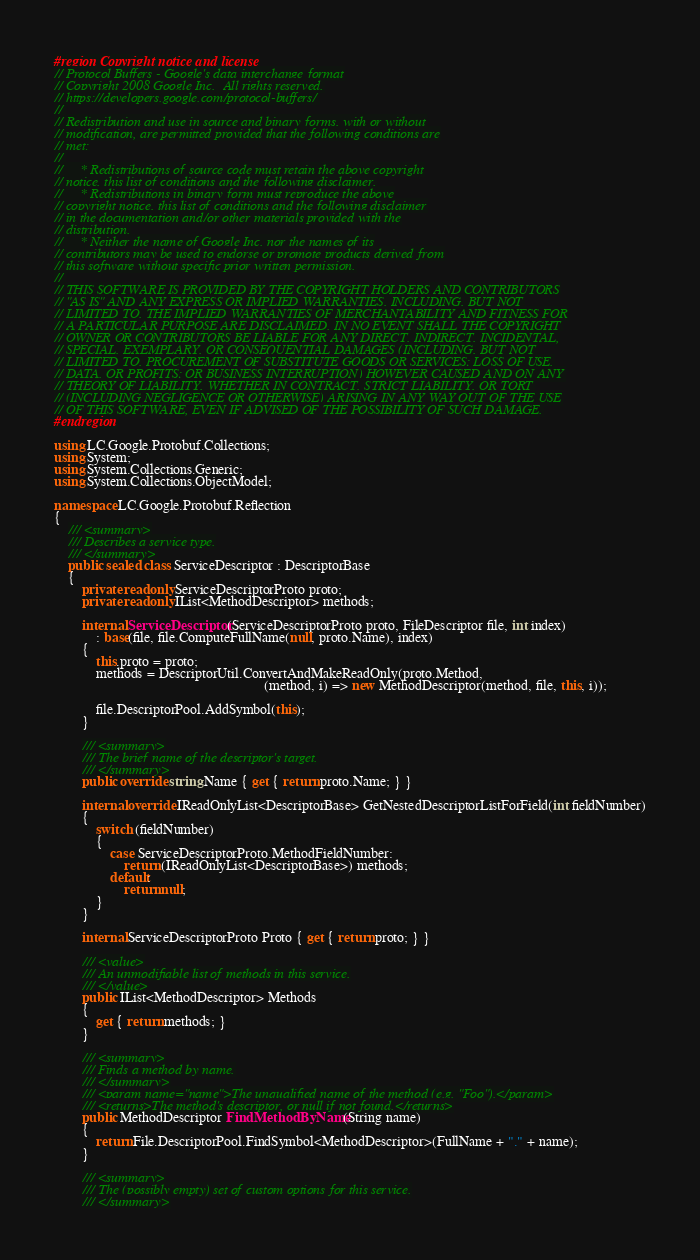<code> <loc_0><loc_0><loc_500><loc_500><_C#_>#region Copyright notice and license
// Protocol Buffers - Google's data interchange format
// Copyright 2008 Google Inc.  All rights reserved.
// https://developers.google.com/protocol-buffers/
//
// Redistribution and use in source and binary forms, with or without
// modification, are permitted provided that the following conditions are
// met:
//
//     * Redistributions of source code must retain the above copyright
// notice, this list of conditions and the following disclaimer.
//     * Redistributions in binary form must reproduce the above
// copyright notice, this list of conditions and the following disclaimer
// in the documentation and/or other materials provided with the
// distribution.
//     * Neither the name of Google Inc. nor the names of its
// contributors may be used to endorse or promote products derived from
// this software without specific prior written permission.
//
// THIS SOFTWARE IS PROVIDED BY THE COPYRIGHT HOLDERS AND CONTRIBUTORS
// "AS IS" AND ANY EXPRESS OR IMPLIED WARRANTIES, INCLUDING, BUT NOT
// LIMITED TO, THE IMPLIED WARRANTIES OF MERCHANTABILITY AND FITNESS FOR
// A PARTICULAR PURPOSE ARE DISCLAIMED. IN NO EVENT SHALL THE COPYRIGHT
// OWNER OR CONTRIBUTORS BE LIABLE FOR ANY DIRECT, INDIRECT, INCIDENTAL,
// SPECIAL, EXEMPLARY, OR CONSEQUENTIAL DAMAGES (INCLUDING, BUT NOT
// LIMITED TO, PROCUREMENT OF SUBSTITUTE GOODS OR SERVICES; LOSS OF USE,
// DATA, OR PROFITS; OR BUSINESS INTERRUPTION) HOWEVER CAUSED AND ON ANY
// THEORY OF LIABILITY, WHETHER IN CONTRACT, STRICT LIABILITY, OR TORT
// (INCLUDING NEGLIGENCE OR OTHERWISE) ARISING IN ANY WAY OUT OF THE USE
// OF THIS SOFTWARE, EVEN IF ADVISED OF THE POSSIBILITY OF SUCH DAMAGE.
#endregion

using LC.Google.Protobuf.Collections;
using System;
using System.Collections.Generic;
using System.Collections.ObjectModel;

namespace LC.Google.Protobuf.Reflection
{
    /// <summary>
    /// Describes a service type.
    /// </summary>
    public sealed class ServiceDescriptor : DescriptorBase
    {
        private readonly ServiceDescriptorProto proto;
        private readonly IList<MethodDescriptor> methods;

        internal ServiceDescriptor(ServiceDescriptorProto proto, FileDescriptor file, int index)
            : base(file, file.ComputeFullName(null, proto.Name), index)
        {
            this.proto = proto;
            methods = DescriptorUtil.ConvertAndMakeReadOnly(proto.Method,
                                                            (method, i) => new MethodDescriptor(method, file, this, i));

            file.DescriptorPool.AddSymbol(this);
        }

        /// <summary>
        /// The brief name of the descriptor's target.
        /// </summary>
        public override string Name { get { return proto.Name; } }

        internal override IReadOnlyList<DescriptorBase> GetNestedDescriptorListForField(int fieldNumber)
        {
            switch (fieldNumber)
            {
                case ServiceDescriptorProto.MethodFieldNumber:
                    return (IReadOnlyList<DescriptorBase>) methods;
                default:
                    return null;
            }
        }

        internal ServiceDescriptorProto Proto { get { return proto; } }

        /// <value>
        /// An unmodifiable list of methods in this service.
        /// </value>
        public IList<MethodDescriptor> Methods
        {
            get { return methods; }
        }

        /// <summary>
        /// Finds a method by name.
        /// </summary>
        /// <param name="name">The unqualified name of the method (e.g. "Foo").</param>
        /// <returns>The method's descriptor, or null if not found.</returns>
        public MethodDescriptor FindMethodByName(String name)
        {
            return File.DescriptorPool.FindSymbol<MethodDescriptor>(FullName + "." + name);
        }

        /// <summary>
        /// The (possibly empty) set of custom options for this service.
        /// </summary></code> 